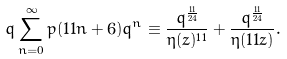<formula> <loc_0><loc_0><loc_500><loc_500>q \sum _ { n = 0 } ^ { \infty } p ( 1 1 n + 6 ) q ^ { n } \equiv \frac { q ^ { \frac { 1 1 } { 2 4 } } } { \eta ( z ) ^ { 1 1 } } + \frac { q ^ { \frac { 1 1 } { 2 4 } } } { \eta ( 1 1 z ) } .</formula> 